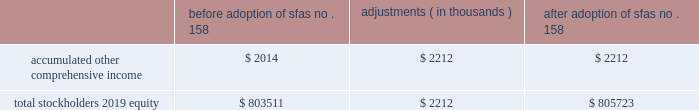Table of contents hologic , inc .
Notes to consolidated financial statements ( continued ) ( in thousands , except per share data ) as of september 26 , 2009 , the company 2019s financial assets that are re-measured at fair value on a recurring basis consisted of $ 313 in money market mutual funds that are classified as cash and cash equivalents in the consolidated balance sheets .
As there are no withdrawal restrictions , they are classified within level 1 of the fair value hierarchy and are valued using quoted market prices for identical assets .
The company holds certain minority cost-method equity investments in non-publicly traded securities aggregating $ 7585 and $ 9278 at september 26 , 2009 and september 27 , 2008 , respectively , which are included in other long-term assets on the company 2019s consolidated balance sheets .
These investments are generally carried at cost .
As the inputs utilized for the company 2019s periodic impairment assessment are not based on observable market data , these cost method investments are classified within level 3 of the fair value hierarchy on a non-recurring basis .
To determine the fair value of these investments , the company uses all available financial information related to the entities , including information based on recent or pending third-party equity investments in these entities .
In certain instances , a cost method investment 2019s fair value is not estimated as there are no identified events or changes in circumstances that may have a significant adverse effect on the fair value of the investment and to do so would be impractical .
During fiscal 2009 , the company recorded other-than-temporary impairment charges totaling $ 2243 related to two of its cost method investments to adjust their carrying amounts to fair value .
Pension and other employee benefits the company has certain defined benefit pension plans covering the employees of its aeg german subsidiary ( the 201cpension benefits 201d ) .
As of september 29 , 2007 , the company adopted sfas no .
158 , employers 2019 accounting for defined benefit pension and other postretirement plans , an amendment of fasb statements no .
87 , 88 , 106 and 132 ( r ) ( codified primarily in asc 715 , defined benefit plans ) using a prospective approach .
The adoption of this standard did not impact the company 2019s compliance with its debt covenants under its credit agreements , cash position or results of operations .
The table summarizes the incremental effect of adopting this standard on individual line items in the consolidated balance sheet as of september 29 , 2007 : before adoption of sfas no .
158 adjustments ( in thousands ) adoption of sfas no .
158 .
As of september 26 , 2009 and september 27 , 2008 , the company 2019s pension liability is $ 6736 and $ 7323 , respectively , which is primarily recorded as a component of long-term liabilities in the consolidated balance sheets .
Under german law , there are no rules governing investment or statutory supervision of the pension plan .
As such , there is no minimum funding requirement imposed on employers .
Pension benefits are safeguarded by the pension guaranty fund , a form of compulsory reinsurance that guarantees an employee will receive vested pension benefits in the event of insolvency .
Source : hologic inc , 10-k , november 24 , 2009 powered by morningstar ae document research 2120 the information contained herein may not be copied , adapted or distributed and is not warranted to be accurate , complete or timely .
The user assumes all risks for any damages or losses arising from any use of this information , except to the extent such damages or losses cannot be limited or excluded by applicable law .
Past financial performance is no guarantee of future results. .
What is the net change in the equity investments in non-publicly traded securities from 2008 to 2009? 
Computations: (7585 - 9278)
Answer: -1693.0. 